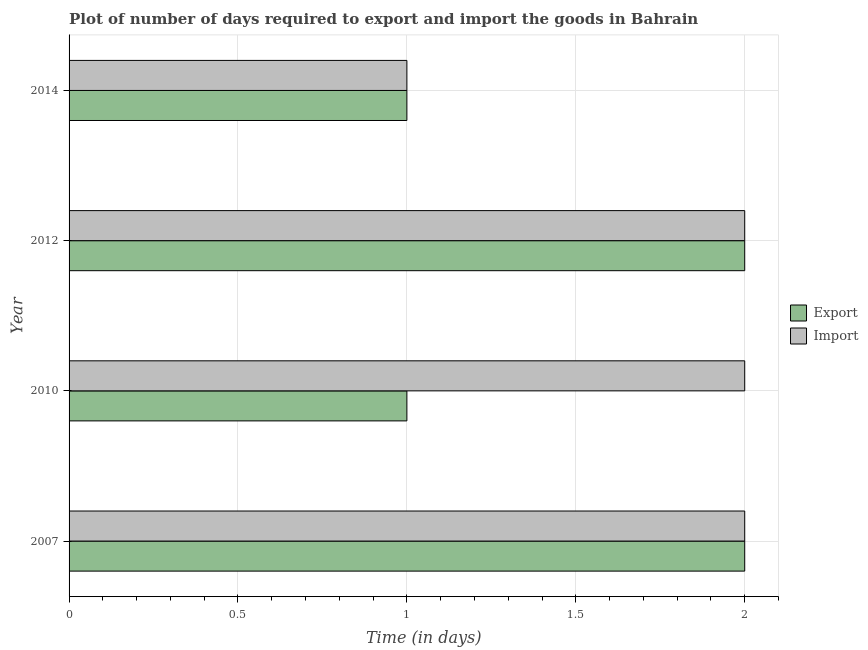Are the number of bars per tick equal to the number of legend labels?
Make the answer very short. Yes. How many bars are there on the 2nd tick from the top?
Your answer should be very brief. 2. In how many cases, is the number of bars for a given year not equal to the number of legend labels?
Ensure brevity in your answer.  0. What is the time required to import in 2012?
Make the answer very short. 2. Across all years, what is the maximum time required to import?
Ensure brevity in your answer.  2. Across all years, what is the minimum time required to import?
Provide a succinct answer. 1. What is the total time required to export in the graph?
Your answer should be very brief. 6. What is the difference between the time required to import in 2010 and the time required to export in 2014?
Ensure brevity in your answer.  1. What is the average time required to export per year?
Your response must be concise. 1.5. Is the time required to import in 2007 less than that in 2010?
Give a very brief answer. No. What is the difference between the highest and the lowest time required to export?
Your response must be concise. 1. In how many years, is the time required to import greater than the average time required to import taken over all years?
Offer a very short reply. 3. What does the 1st bar from the top in 2014 represents?
Your answer should be very brief. Import. What does the 2nd bar from the bottom in 2012 represents?
Give a very brief answer. Import. How many bars are there?
Keep it short and to the point. 8. What is the difference between two consecutive major ticks on the X-axis?
Your answer should be very brief. 0.5. Are the values on the major ticks of X-axis written in scientific E-notation?
Offer a terse response. No. Does the graph contain grids?
Offer a terse response. Yes. How are the legend labels stacked?
Your answer should be compact. Vertical. What is the title of the graph?
Offer a very short reply. Plot of number of days required to export and import the goods in Bahrain. What is the label or title of the X-axis?
Provide a succinct answer. Time (in days). What is the Time (in days) of Export in 2007?
Offer a terse response. 2. What is the Time (in days) in Export in 2010?
Your answer should be very brief. 1. What is the Time (in days) in Export in 2012?
Give a very brief answer. 2. What is the Time (in days) of Import in 2012?
Give a very brief answer. 2. What is the Time (in days) in Export in 2014?
Ensure brevity in your answer.  1. What is the Time (in days) of Import in 2014?
Make the answer very short. 1. Across all years, what is the minimum Time (in days) of Export?
Keep it short and to the point. 1. Across all years, what is the minimum Time (in days) in Import?
Ensure brevity in your answer.  1. What is the total Time (in days) of Import in the graph?
Offer a very short reply. 7. What is the difference between the Time (in days) in Export in 2007 and that in 2010?
Provide a short and direct response. 1. What is the difference between the Time (in days) in Import in 2007 and that in 2010?
Ensure brevity in your answer.  0. What is the difference between the Time (in days) of Import in 2007 and that in 2012?
Your answer should be compact. 0. What is the difference between the Time (in days) of Export in 2007 and that in 2014?
Provide a succinct answer. 1. What is the difference between the Time (in days) in Export in 2010 and that in 2012?
Keep it short and to the point. -1. What is the difference between the Time (in days) of Import in 2012 and that in 2014?
Give a very brief answer. 1. What is the difference between the Time (in days) of Export in 2007 and the Time (in days) of Import in 2010?
Ensure brevity in your answer.  0. What is the difference between the Time (in days) of Export in 2007 and the Time (in days) of Import in 2012?
Offer a very short reply. 0. What is the difference between the Time (in days) in Export in 2007 and the Time (in days) in Import in 2014?
Your answer should be very brief. 1. What is the difference between the Time (in days) in Export in 2010 and the Time (in days) in Import in 2014?
Ensure brevity in your answer.  0. What is the difference between the Time (in days) of Export in 2012 and the Time (in days) of Import in 2014?
Your answer should be compact. 1. What is the average Time (in days) of Export per year?
Give a very brief answer. 1.5. In the year 2012, what is the difference between the Time (in days) of Export and Time (in days) of Import?
Offer a very short reply. 0. What is the ratio of the Time (in days) of Import in 2007 to that in 2014?
Make the answer very short. 2. What is the ratio of the Time (in days) in Export in 2010 to that in 2012?
Your response must be concise. 0.5. What is the ratio of the Time (in days) of Export in 2010 to that in 2014?
Offer a very short reply. 1. What is the ratio of the Time (in days) of Import in 2010 to that in 2014?
Keep it short and to the point. 2. What is the ratio of the Time (in days) of Export in 2012 to that in 2014?
Give a very brief answer. 2. What is the difference between the highest and the second highest Time (in days) of Export?
Ensure brevity in your answer.  0. What is the difference between the highest and the second highest Time (in days) in Import?
Offer a very short reply. 0. What is the difference between the highest and the lowest Time (in days) of Import?
Your answer should be very brief. 1. 